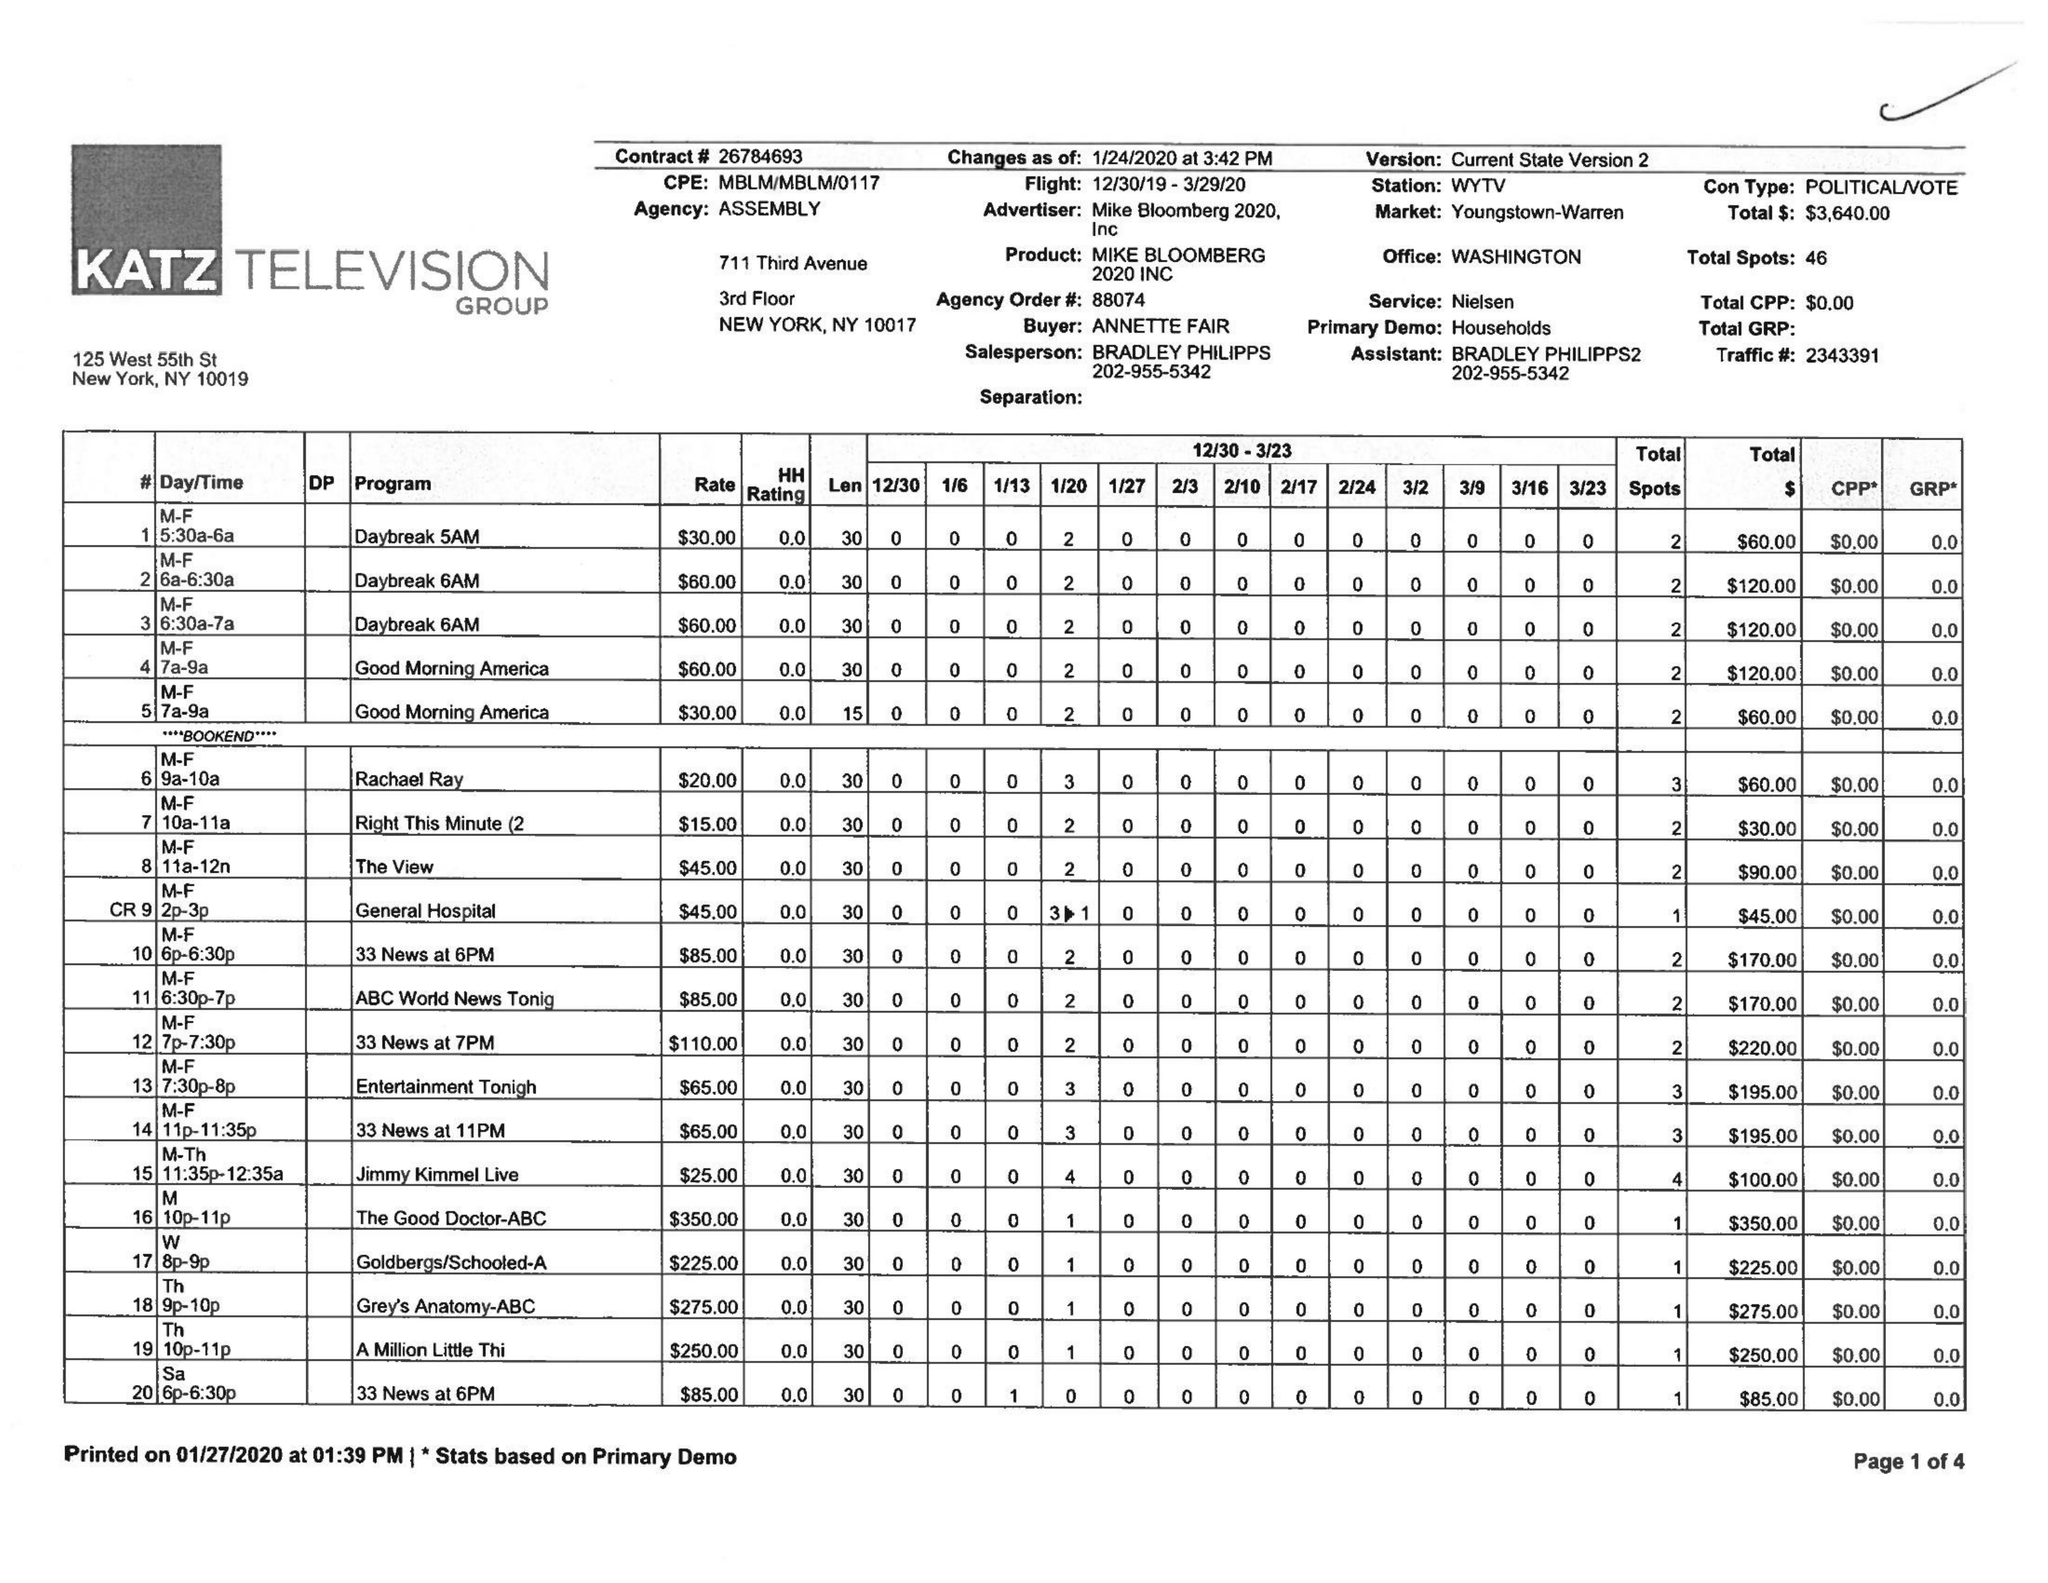What is the value for the flight_to?
Answer the question using a single word or phrase. 03/29/20 